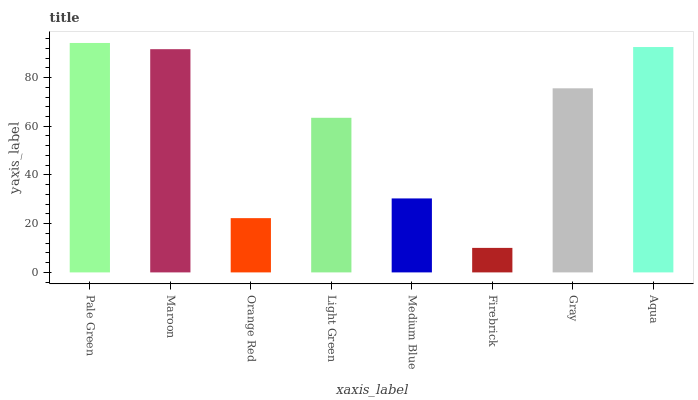Is Firebrick the minimum?
Answer yes or no. Yes. Is Pale Green the maximum?
Answer yes or no. Yes. Is Maroon the minimum?
Answer yes or no. No. Is Maroon the maximum?
Answer yes or no. No. Is Pale Green greater than Maroon?
Answer yes or no. Yes. Is Maroon less than Pale Green?
Answer yes or no. Yes. Is Maroon greater than Pale Green?
Answer yes or no. No. Is Pale Green less than Maroon?
Answer yes or no. No. Is Gray the high median?
Answer yes or no. Yes. Is Light Green the low median?
Answer yes or no. Yes. Is Orange Red the high median?
Answer yes or no. No. Is Medium Blue the low median?
Answer yes or no. No. 